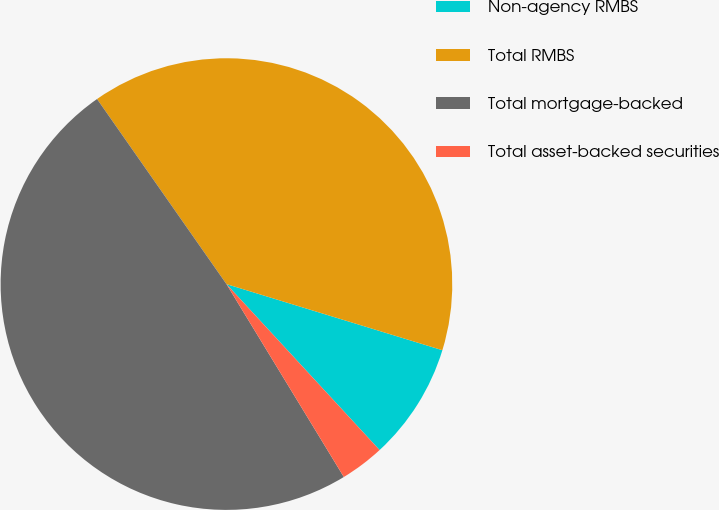<chart> <loc_0><loc_0><loc_500><loc_500><pie_chart><fcel>Non-agency RMBS<fcel>Total RMBS<fcel>Total mortgage-backed<fcel>Total asset-backed securities<nl><fcel>8.41%<fcel>39.44%<fcel>48.99%<fcel>3.16%<nl></chart> 